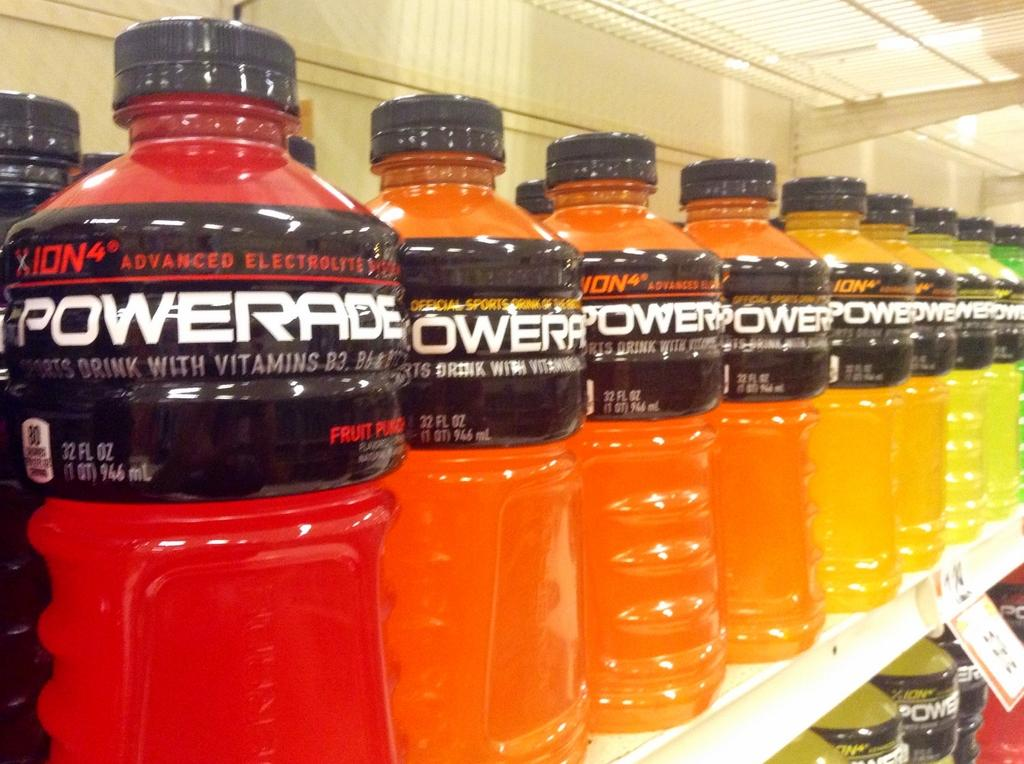<image>
Present a compact description of the photo's key features. The Powerade display is arranged by flavor starting with fruit punch. 